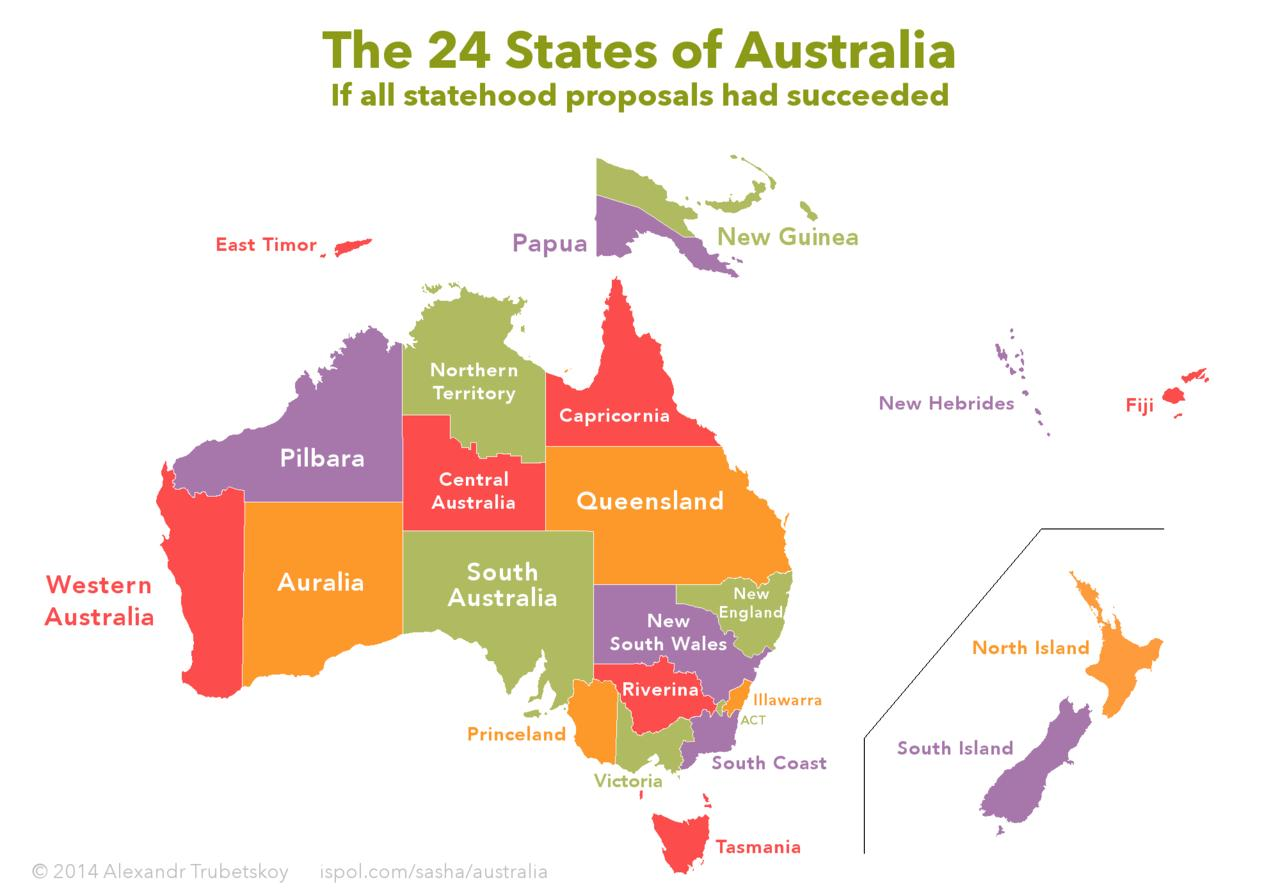Give some essential details in this illustration. Fiji Island is known for having a red or purple color, with many people believing it to be red. Central Australia is the state that lies between Northern Territory and South Australia. Western Australia is located between the states of South Australia and Auralia. East Timor is the island to the left of Papua. The island shown in orange is the North Island. 